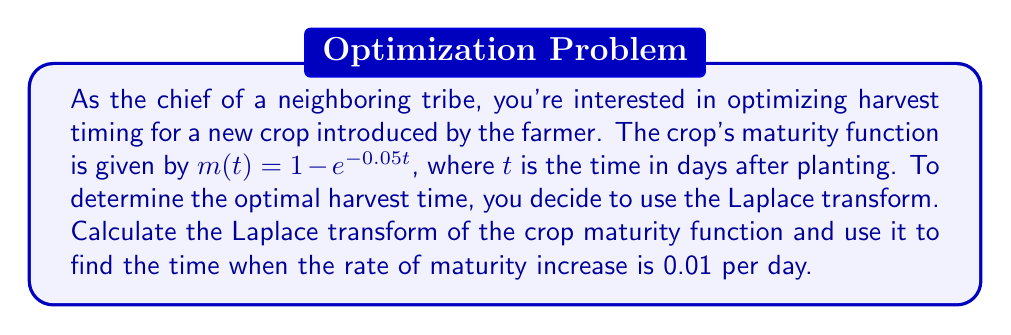Provide a solution to this math problem. To solve this problem, we'll follow these steps:

1) First, let's find the Laplace transform of the maturity function $m(t) = 1 - e^{-0.05t}$.

   The Laplace transform is defined as:
   $$\mathcal{L}\{f(t)\} = F(s) = \int_0^\infty e^{-st}f(t)dt$$

   For our function:
   $$\begin{align}
   \mathcal{L}\{m(t)\} &= \mathcal{L}\{1 - e^{-0.05t}\} \\
   &= \mathcal{L}\{1\} - \mathcal{L}\{e^{-0.05t}\}
   \end{align}$$

   We know that $\mathcal{L}\{1\} = \frac{1}{s}$ and $\mathcal{L}\{e^{-at}\} = \frac{1}{s+a}$

   Therefore:
   $$\mathcal{L}\{m(t)\} = \frac{1}{s} - \frac{1}{s+0.05} = \frac{0.05}{s(s+0.05)}$$

2) Now, to find the rate of maturity increase, we need to differentiate $m(t)$:

   $$\frac{d}{dt}m(t) = \frac{d}{dt}(1 - e^{-0.05t}) = 0.05e^{-0.05t}$$

3) We want to find when this rate equals 0.01:

   $$0.05e^{-0.05t} = 0.01$$

4) Solving for $t$:

   $$\begin{align}
   e^{-0.05t} &= 0.2 \\
   -0.05t &= \ln(0.2) \\
   t &= -\frac{\ln(0.2)}{0.05} \approx 32.19 \text{ days}
   \end{align}$$

Therefore, the rate of maturity increase will be 0.01 per day approximately 32.19 days after planting.
Answer: The Laplace transform of the crop maturity function is $\frac{0.05}{s(s+0.05)}$, and the optimal harvest time when the rate of maturity increase is 0.01 per day is approximately 32.19 days after planting. 